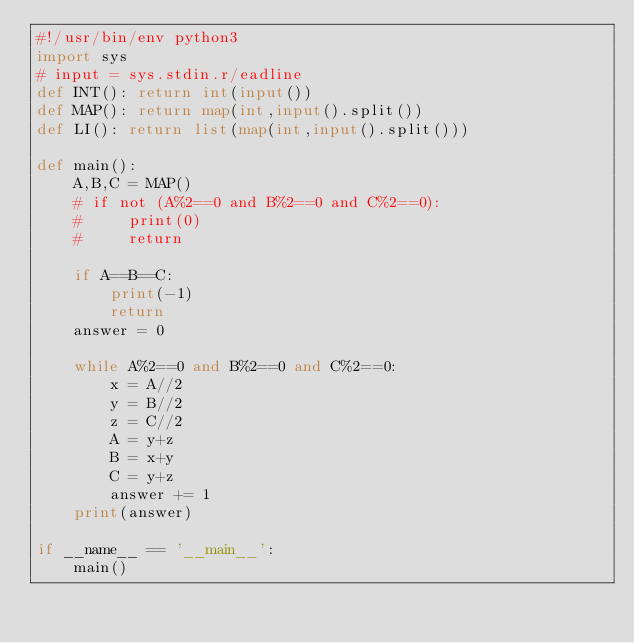Convert code to text. <code><loc_0><loc_0><loc_500><loc_500><_Python_>#!/usr/bin/env python3
import sys
# input = sys.stdin.r/eadline
def INT(): return int(input())
def MAP(): return map(int,input().split())
def LI(): return list(map(int,input().split()))

def main():
    A,B,C = MAP()
    # if not (A%2==0 and B%2==0 and C%2==0):
    #     print(0)
    #     return

    if A==B==C:
        print(-1)
        return
    answer = 0
    
    while A%2==0 and B%2==0 and C%2==0:
        x = A//2
        y = B//2
        z = C//2
        A = y+z
        B = x+y
        C = y+z
        answer += 1
    print(answer)

if __name__ == '__main__':
    main()
</code> 